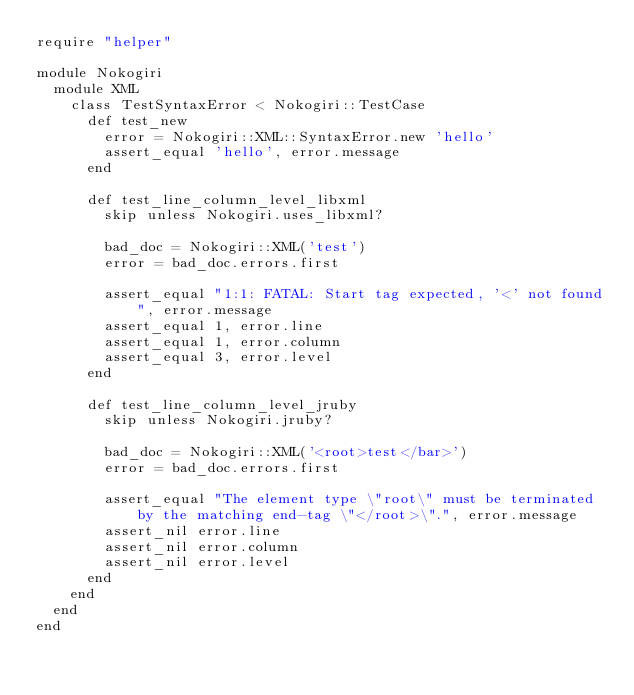<code> <loc_0><loc_0><loc_500><loc_500><_Ruby_>require "helper"

module Nokogiri
  module XML
    class TestSyntaxError < Nokogiri::TestCase
      def test_new
        error = Nokogiri::XML::SyntaxError.new 'hello'
        assert_equal 'hello', error.message
      end

      def test_line_column_level_libxml
        skip unless Nokogiri.uses_libxml?

        bad_doc = Nokogiri::XML('test')
        error = bad_doc.errors.first

        assert_equal "1:1: FATAL: Start tag expected, '<' not found", error.message
        assert_equal 1, error.line
        assert_equal 1, error.column
        assert_equal 3, error.level
      end

      def test_line_column_level_jruby
        skip unless Nokogiri.jruby?

        bad_doc = Nokogiri::XML('<root>test</bar>')
        error = bad_doc.errors.first

        assert_equal "The element type \"root\" must be terminated by the matching end-tag \"</root>\".", error.message
        assert_nil error.line
        assert_nil error.column
        assert_nil error.level
      end
    end
  end
end
</code> 